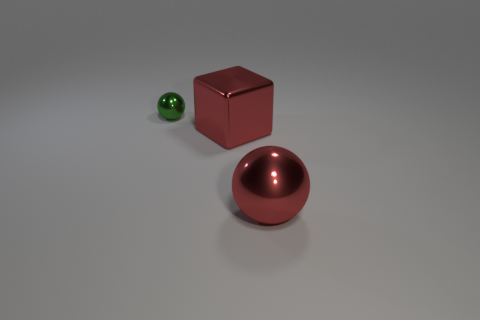What material is the other thing that is the same shape as the green object?
Offer a terse response. Metal. There is a big red object on the left side of the shiny sphere that is in front of the cube; what is it made of?
Offer a terse response. Metal. There is a large object that is in front of the big red metal cube; is its color the same as the big cube?
Your answer should be compact. Yes. Is there anything else that has the same material as the cube?
Your answer should be very brief. Yes. How many small rubber objects have the same shape as the tiny green shiny thing?
Keep it short and to the point. 0. There is a red ball that is made of the same material as the small thing; what size is it?
Make the answer very short. Large. There is a metal sphere left of the shiny sphere in front of the tiny ball; are there any tiny spheres that are on the right side of it?
Offer a terse response. No. Is the size of the red sphere to the right of the shiny block the same as the green ball?
Provide a succinct answer. No. What number of other red blocks are the same size as the red cube?
Provide a short and direct response. 0. What size is the ball that is the same color as the large shiny block?
Your answer should be very brief. Large. 